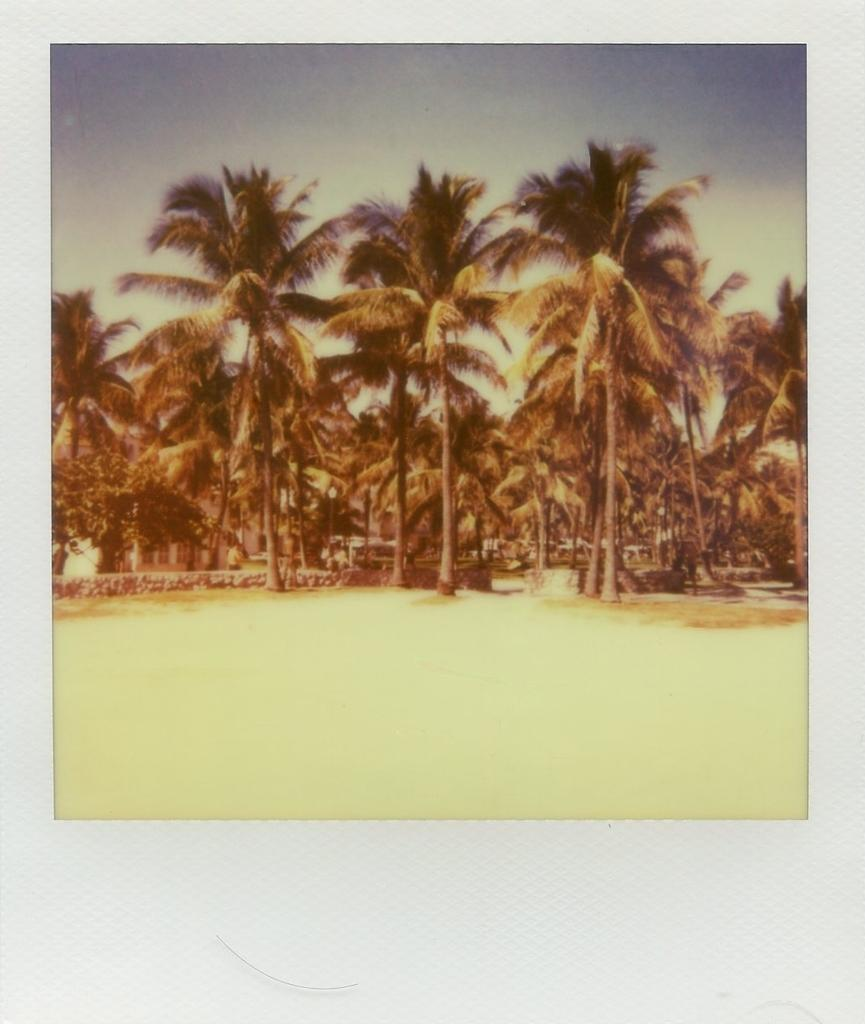What type of vegetation can be seen in the image? There are trees in the image. What part of the natural environment is visible in the image? The sky is visible in the image. What is the surface on which the trees are standing? There is ground at the bottom of the image. What type of insurance policy is being advertised on the trees in the image? There is no insurance policy or advertisement present in the image; it only features trees, sky, and ground. 